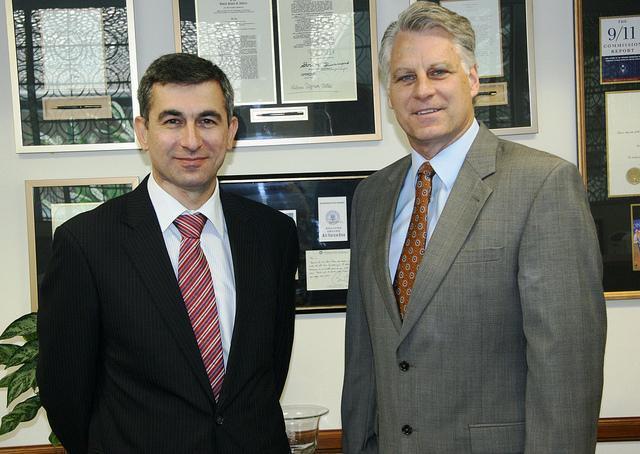How many men are wearing ties?
Give a very brief answer. 2. How many ties are in the picture?
Give a very brief answer. 2. How many people are in the picture?
Give a very brief answer. 2. How many cars can be seen in the picture?
Give a very brief answer. 0. 